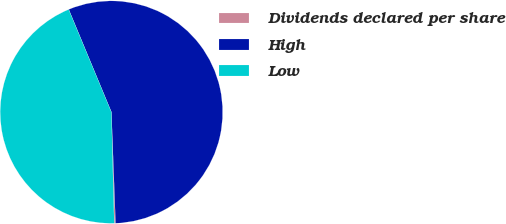<chart> <loc_0><loc_0><loc_500><loc_500><pie_chart><fcel>Dividends declared per share<fcel>High<fcel>Low<nl><fcel>0.19%<fcel>55.68%<fcel>44.13%<nl></chart> 